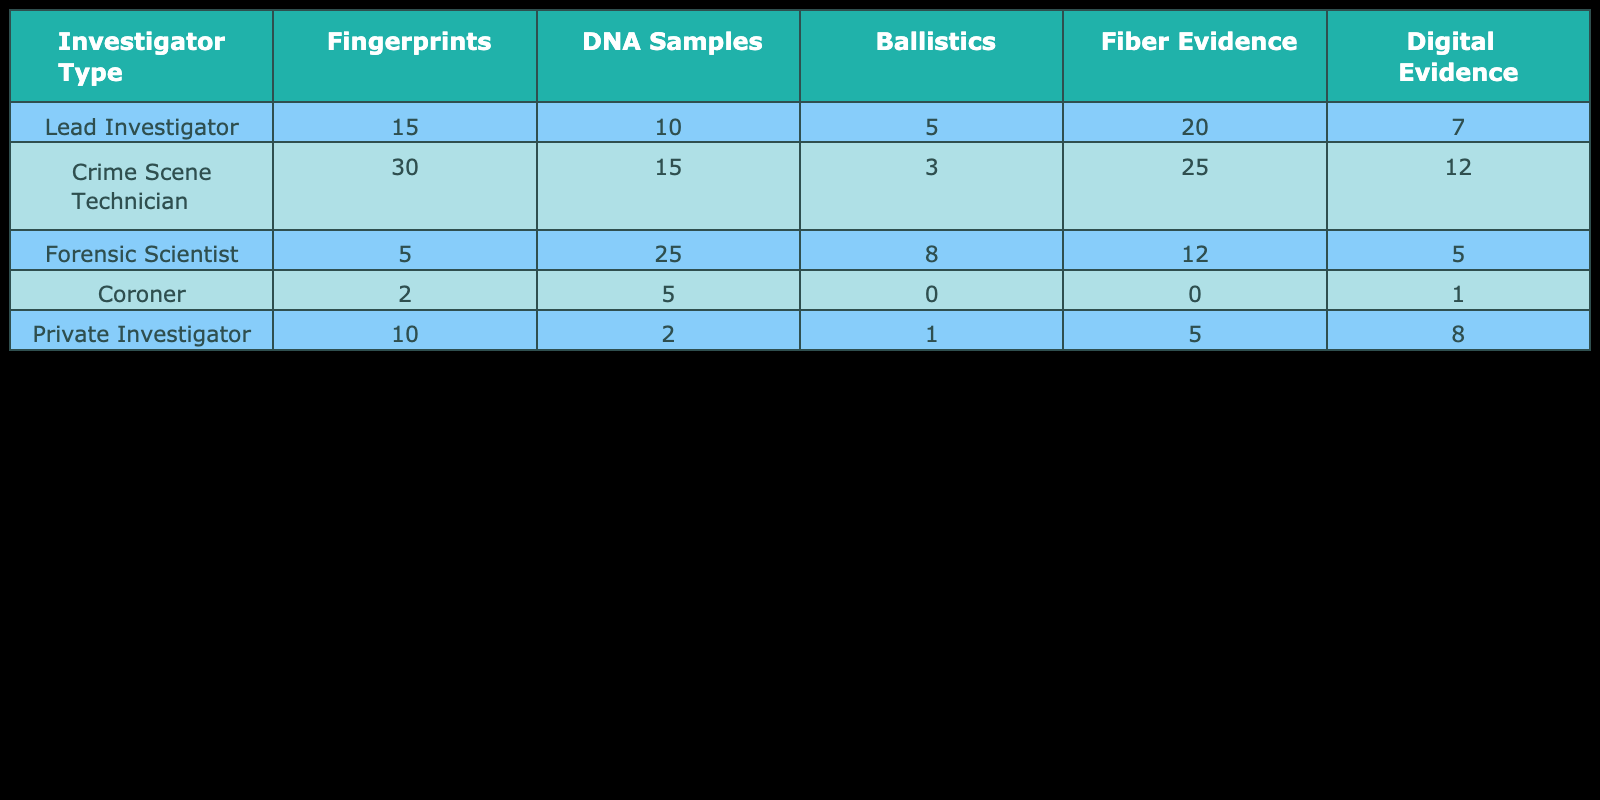What is the total number of fingerprints collected by all investigators? To find the total number of fingerprints collected, sum the values under the "Fingerprints" column: 15 + 30 + 5 + 2 + 10 = 62.
Answer: 62 Which investigator collected the highest number of DNA samples? By comparing the values in the "DNA Samples" column, the highest value is 25, which corresponds to the Forensic Scientist.
Answer: Forensic Scientist How many pieces of fiber evidence were collected by the Crime Scene Technician? The value in the "Fiber Evidence" column for the Crime Scene Technician is 25.
Answer: 25 Did the Coroner collect any ballistic evidence? Checking the "Ballistics" column for the Coroner reveals a value of 0, indicating no ballistic evidence was collected.
Answer: No What is the average number of digital evidence collected across all investigators? To find the average of the "Digital Evidence" column, first sum the values: 7 + 12 + 5 + 1 + 8 = 33; then divide by the total number of investigators (5): 33 / 5 = 6.6.
Answer: 6.6 Which type of evidence was most frequently collected by the Lead Investigator? The Lead Investigator collected the highest quantity of "Fiber Evidence," with a total of 20 collected.
Answer: Fiber Evidence If we combine the total number of DNA samples from the Lead Investigator and Crime Scene Technician, what is that total? Adding the DNA samples from both investigators: 10 (Lead Investigator) + 15 (Crime Scene Technician) = 25.
Answer: 25 Is the amount of ballistic evidence collected by the Private Investigator greater than that collected by the Coroner? The Private Investigator collected 1 of ballistic evidence, while the Coroner collected 0. Since 1 is greater than 0, the statement is true.
Answer: Yes What is the difference in the number of fingerprints collected by the Crime Scene Technician and the Private Investigator? The Crime Scene Technician collected 30 fingerprints, and the Private Investigator collected 10; the difference is 30 - 10 = 20.
Answer: 20 